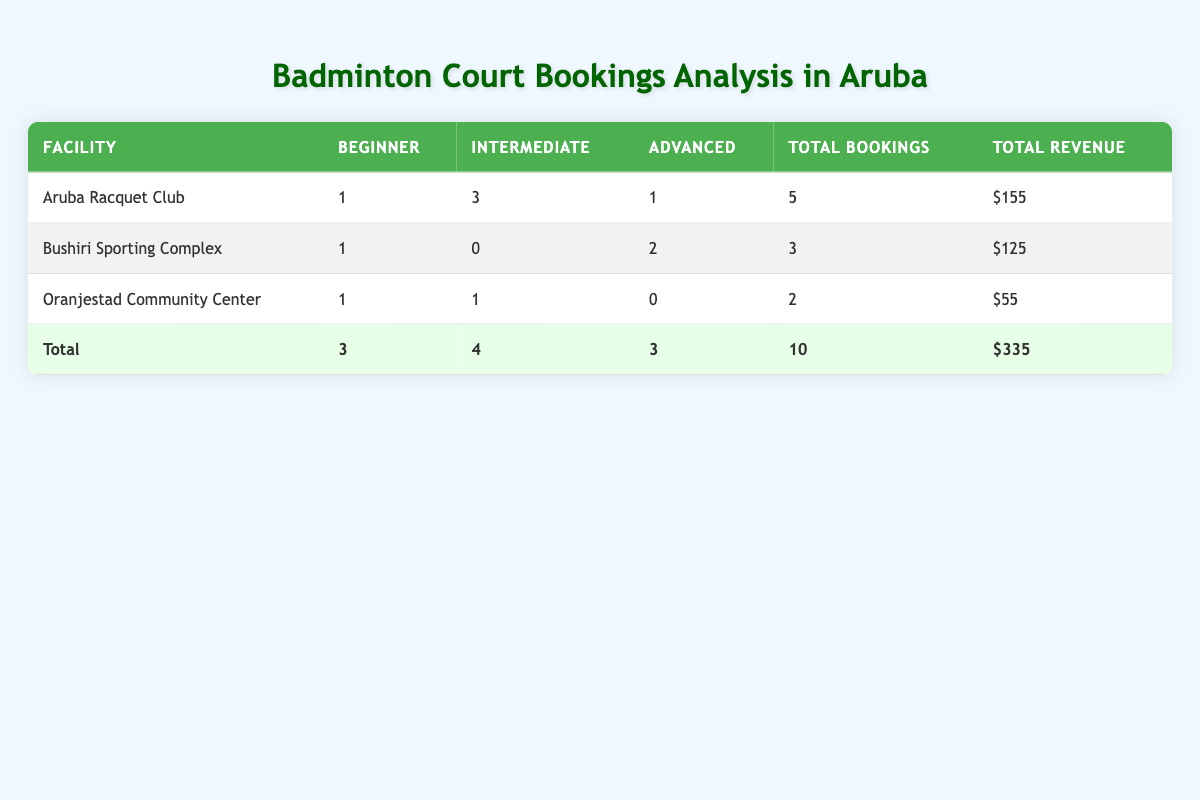What is the total number of bookings across all facilities? To find the total number of bookings, we sum the values in the 'Total Bookings' column: 5 (Aruba Racquet Club) + 3 (Bushiri Sporting Complex) + 2 (Oranjestad Community Center) = 10.
Answer: 10 Which facility had the highest total revenue? By comparing the 'Total Revenue' column, we see Aruba Racquet Club has $155, Bushiri Sporting Complex has $125, and Oranjestad Community Center has $55. Therefore, Aruba Racquet Club has the highest revenue.
Answer: Aruba Racquet Club How many bookings were made by Intermediate players at the Aruba Racquet Club? From the table, we can see there are 3 bookings under Intermediate for the Aruba Racquet Club.
Answer: 3 Did all facilities have Beginner level bookings? Checking the 'Beginner' column, we see that all facilities have at least one booking: 1 for Aruba Racquet Club, 1 for Bushiri Sporting Complex, and 1 for Oranjestad Community Center. Therefore, the answer is yes.
Answer: Yes What is the average revenue generated per booking for Bushiri Sporting Complex? The total revenue for Bushiri Sporting Complex is $125, and it had 3 bookings. To find the average, we divide total revenue by total bookings: 125 / 3 = 41.67.
Answer: 41.67 What is the total number of Advanced player bookings at any facility? In the 'Advanced' column, there are 1 (Aruba Racquet Club) + 2 (Bushiri Sporting Complex) + 0 (Oranjestad Community Center) = 3 total Advanced bookings.
Answer: 3 How many more Intermediate bookings does Aruba Racquet Club have compared to Bushiri Sporting Complex? Aruba Racquet Club has 3 Intermediate bookings and Bushiri Sporting Complex has 0. The difference is 3 - 0 = 3.
Answer: 3 Is the total revenue for Oranjestad Community Center greater than or equal to the total revenue for Bushiri Sporting Complex? The total revenue for Oranjestad Community Center is $55 and for Bushiri Sporting Complex it is $125. Since 55 is less than 125, the statement is false.
Answer: No What percentage of total bookings were for doubles? We total the bookings for doubles which is 2 (Bushiri Sporting Complex) + 2 (Oranjestad Community Center) + 4 (Aruba Racquet Club) = 8 doubles. Total bookings are 10. So, the percentage of doubles bookings is (6 / 10) * 100 = 60%.
Answer: 60% 